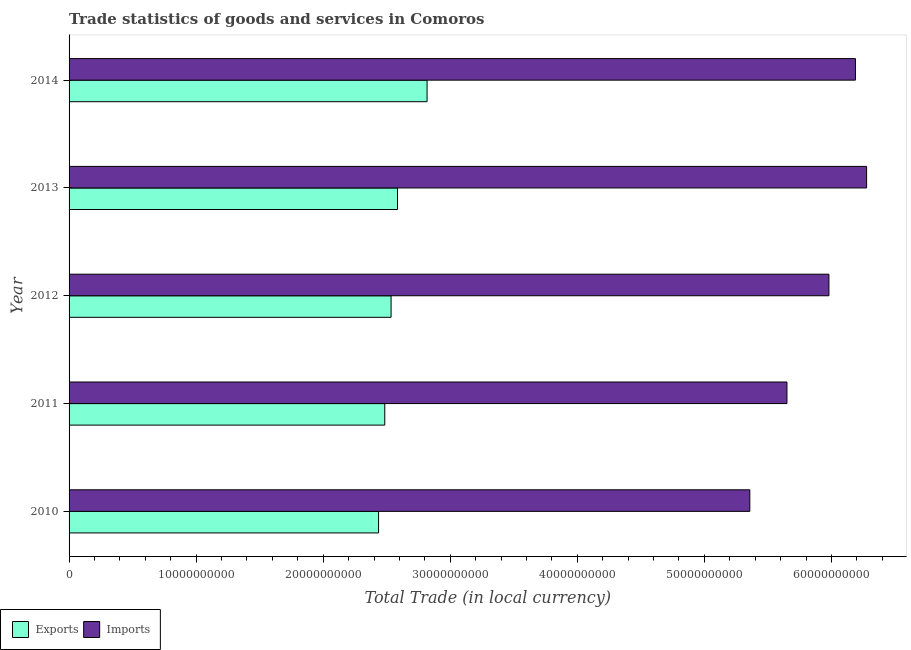How many bars are there on the 1st tick from the top?
Give a very brief answer. 2. How many bars are there on the 2nd tick from the bottom?
Provide a short and direct response. 2. What is the imports of goods and services in 2012?
Make the answer very short. 5.98e+1. Across all years, what is the maximum export of goods and services?
Keep it short and to the point. 2.82e+1. Across all years, what is the minimum imports of goods and services?
Keep it short and to the point. 5.36e+1. In which year was the export of goods and services maximum?
Give a very brief answer. 2014. In which year was the imports of goods and services minimum?
Make the answer very short. 2010. What is the total imports of goods and services in the graph?
Provide a succinct answer. 2.95e+11. What is the difference between the export of goods and services in 2010 and that in 2012?
Give a very brief answer. -9.84e+08. What is the difference between the export of goods and services in 2014 and the imports of goods and services in 2012?
Your answer should be compact. -3.16e+1. What is the average export of goods and services per year?
Give a very brief answer. 2.57e+1. In the year 2012, what is the difference between the export of goods and services and imports of goods and services?
Keep it short and to the point. -3.45e+1. What is the ratio of the export of goods and services in 2012 to that in 2014?
Provide a short and direct response. 0.9. Is the difference between the export of goods and services in 2010 and 2012 greater than the difference between the imports of goods and services in 2010 and 2012?
Provide a short and direct response. Yes. What is the difference between the highest and the second highest export of goods and services?
Ensure brevity in your answer.  2.33e+09. What is the difference between the highest and the lowest imports of goods and services?
Ensure brevity in your answer.  9.19e+09. In how many years, is the imports of goods and services greater than the average imports of goods and services taken over all years?
Offer a very short reply. 3. What does the 1st bar from the top in 2011 represents?
Offer a terse response. Imports. What does the 1st bar from the bottom in 2014 represents?
Your answer should be very brief. Exports. How many bars are there?
Make the answer very short. 10. What is the difference between two consecutive major ticks on the X-axis?
Keep it short and to the point. 1.00e+1. Are the values on the major ticks of X-axis written in scientific E-notation?
Keep it short and to the point. No. Does the graph contain grids?
Your answer should be very brief. No. How many legend labels are there?
Provide a succinct answer. 2. How are the legend labels stacked?
Your answer should be compact. Horizontal. What is the title of the graph?
Keep it short and to the point. Trade statistics of goods and services in Comoros. Does "Constant 2005 US$" appear as one of the legend labels in the graph?
Your response must be concise. No. What is the label or title of the X-axis?
Your answer should be very brief. Total Trade (in local currency). What is the Total Trade (in local currency) of Exports in 2010?
Make the answer very short. 2.44e+1. What is the Total Trade (in local currency) of Imports in 2010?
Your answer should be very brief. 5.36e+1. What is the Total Trade (in local currency) in Exports in 2011?
Your answer should be compact. 2.48e+1. What is the Total Trade (in local currency) in Imports in 2011?
Give a very brief answer. 5.65e+1. What is the Total Trade (in local currency) in Exports in 2012?
Provide a succinct answer. 2.53e+1. What is the Total Trade (in local currency) of Imports in 2012?
Keep it short and to the point. 5.98e+1. What is the Total Trade (in local currency) in Exports in 2013?
Give a very brief answer. 2.58e+1. What is the Total Trade (in local currency) of Imports in 2013?
Keep it short and to the point. 6.28e+1. What is the Total Trade (in local currency) in Exports in 2014?
Provide a short and direct response. 2.82e+1. What is the Total Trade (in local currency) of Imports in 2014?
Offer a very short reply. 6.19e+1. Across all years, what is the maximum Total Trade (in local currency) in Exports?
Offer a terse response. 2.82e+1. Across all years, what is the maximum Total Trade (in local currency) in Imports?
Give a very brief answer. 6.28e+1. Across all years, what is the minimum Total Trade (in local currency) of Exports?
Keep it short and to the point. 2.44e+1. Across all years, what is the minimum Total Trade (in local currency) of Imports?
Your answer should be very brief. 5.36e+1. What is the total Total Trade (in local currency) of Exports in the graph?
Provide a succinct answer. 1.29e+11. What is the total Total Trade (in local currency) in Imports in the graph?
Offer a very short reply. 2.95e+11. What is the difference between the Total Trade (in local currency) in Exports in 2010 and that in 2011?
Provide a short and direct response. -4.87e+08. What is the difference between the Total Trade (in local currency) in Imports in 2010 and that in 2011?
Offer a very short reply. -2.92e+09. What is the difference between the Total Trade (in local currency) of Exports in 2010 and that in 2012?
Your answer should be very brief. -9.84e+08. What is the difference between the Total Trade (in local currency) of Imports in 2010 and that in 2012?
Make the answer very short. -6.23e+09. What is the difference between the Total Trade (in local currency) of Exports in 2010 and that in 2013?
Ensure brevity in your answer.  -1.49e+09. What is the difference between the Total Trade (in local currency) in Imports in 2010 and that in 2013?
Give a very brief answer. -9.19e+09. What is the difference between the Total Trade (in local currency) in Exports in 2010 and that in 2014?
Provide a succinct answer. -3.82e+09. What is the difference between the Total Trade (in local currency) in Imports in 2010 and that in 2014?
Make the answer very short. -8.31e+09. What is the difference between the Total Trade (in local currency) in Exports in 2011 and that in 2012?
Provide a short and direct response. -4.97e+08. What is the difference between the Total Trade (in local currency) in Imports in 2011 and that in 2012?
Give a very brief answer. -3.30e+09. What is the difference between the Total Trade (in local currency) of Exports in 2011 and that in 2013?
Ensure brevity in your answer.  -1.00e+09. What is the difference between the Total Trade (in local currency) of Imports in 2011 and that in 2013?
Your answer should be compact. -6.27e+09. What is the difference between the Total Trade (in local currency) in Exports in 2011 and that in 2014?
Make the answer very short. -3.33e+09. What is the difference between the Total Trade (in local currency) in Imports in 2011 and that in 2014?
Provide a short and direct response. -5.39e+09. What is the difference between the Total Trade (in local currency) in Exports in 2012 and that in 2013?
Offer a terse response. -5.07e+08. What is the difference between the Total Trade (in local currency) in Imports in 2012 and that in 2013?
Keep it short and to the point. -2.97e+09. What is the difference between the Total Trade (in local currency) in Exports in 2012 and that in 2014?
Your answer should be very brief. -2.83e+09. What is the difference between the Total Trade (in local currency) in Imports in 2012 and that in 2014?
Provide a succinct answer. -2.09e+09. What is the difference between the Total Trade (in local currency) of Exports in 2013 and that in 2014?
Keep it short and to the point. -2.33e+09. What is the difference between the Total Trade (in local currency) in Imports in 2013 and that in 2014?
Ensure brevity in your answer.  8.79e+08. What is the difference between the Total Trade (in local currency) of Exports in 2010 and the Total Trade (in local currency) of Imports in 2011?
Make the answer very short. -3.21e+1. What is the difference between the Total Trade (in local currency) in Exports in 2010 and the Total Trade (in local currency) in Imports in 2012?
Offer a very short reply. -3.54e+1. What is the difference between the Total Trade (in local currency) of Exports in 2010 and the Total Trade (in local currency) of Imports in 2013?
Provide a short and direct response. -3.84e+1. What is the difference between the Total Trade (in local currency) of Exports in 2010 and the Total Trade (in local currency) of Imports in 2014?
Your answer should be very brief. -3.75e+1. What is the difference between the Total Trade (in local currency) in Exports in 2011 and the Total Trade (in local currency) in Imports in 2012?
Ensure brevity in your answer.  -3.50e+1. What is the difference between the Total Trade (in local currency) in Exports in 2011 and the Total Trade (in local currency) in Imports in 2013?
Your answer should be compact. -3.79e+1. What is the difference between the Total Trade (in local currency) in Exports in 2011 and the Total Trade (in local currency) in Imports in 2014?
Offer a very short reply. -3.70e+1. What is the difference between the Total Trade (in local currency) of Exports in 2012 and the Total Trade (in local currency) of Imports in 2013?
Keep it short and to the point. -3.74e+1. What is the difference between the Total Trade (in local currency) in Exports in 2012 and the Total Trade (in local currency) in Imports in 2014?
Give a very brief answer. -3.65e+1. What is the difference between the Total Trade (in local currency) in Exports in 2013 and the Total Trade (in local currency) in Imports in 2014?
Make the answer very short. -3.60e+1. What is the average Total Trade (in local currency) in Exports per year?
Your response must be concise. 2.57e+1. What is the average Total Trade (in local currency) of Imports per year?
Provide a succinct answer. 5.89e+1. In the year 2010, what is the difference between the Total Trade (in local currency) of Exports and Total Trade (in local currency) of Imports?
Offer a very short reply. -2.92e+1. In the year 2011, what is the difference between the Total Trade (in local currency) in Exports and Total Trade (in local currency) in Imports?
Offer a very short reply. -3.17e+1. In the year 2012, what is the difference between the Total Trade (in local currency) in Exports and Total Trade (in local currency) in Imports?
Keep it short and to the point. -3.45e+1. In the year 2013, what is the difference between the Total Trade (in local currency) of Exports and Total Trade (in local currency) of Imports?
Keep it short and to the point. -3.69e+1. In the year 2014, what is the difference between the Total Trade (in local currency) of Exports and Total Trade (in local currency) of Imports?
Keep it short and to the point. -3.37e+1. What is the ratio of the Total Trade (in local currency) of Exports in 2010 to that in 2011?
Give a very brief answer. 0.98. What is the ratio of the Total Trade (in local currency) of Imports in 2010 to that in 2011?
Your response must be concise. 0.95. What is the ratio of the Total Trade (in local currency) of Exports in 2010 to that in 2012?
Your answer should be very brief. 0.96. What is the ratio of the Total Trade (in local currency) in Imports in 2010 to that in 2012?
Keep it short and to the point. 0.9. What is the ratio of the Total Trade (in local currency) of Exports in 2010 to that in 2013?
Keep it short and to the point. 0.94. What is the ratio of the Total Trade (in local currency) in Imports in 2010 to that in 2013?
Offer a very short reply. 0.85. What is the ratio of the Total Trade (in local currency) of Exports in 2010 to that in 2014?
Provide a succinct answer. 0.86. What is the ratio of the Total Trade (in local currency) of Imports in 2010 to that in 2014?
Offer a very short reply. 0.87. What is the ratio of the Total Trade (in local currency) of Exports in 2011 to that in 2012?
Offer a terse response. 0.98. What is the ratio of the Total Trade (in local currency) in Imports in 2011 to that in 2012?
Provide a short and direct response. 0.94. What is the ratio of the Total Trade (in local currency) of Exports in 2011 to that in 2013?
Keep it short and to the point. 0.96. What is the ratio of the Total Trade (in local currency) in Imports in 2011 to that in 2013?
Ensure brevity in your answer.  0.9. What is the ratio of the Total Trade (in local currency) in Exports in 2011 to that in 2014?
Your response must be concise. 0.88. What is the ratio of the Total Trade (in local currency) of Imports in 2011 to that in 2014?
Keep it short and to the point. 0.91. What is the ratio of the Total Trade (in local currency) of Exports in 2012 to that in 2013?
Offer a terse response. 0.98. What is the ratio of the Total Trade (in local currency) in Imports in 2012 to that in 2013?
Provide a short and direct response. 0.95. What is the ratio of the Total Trade (in local currency) in Exports in 2012 to that in 2014?
Keep it short and to the point. 0.9. What is the ratio of the Total Trade (in local currency) of Imports in 2012 to that in 2014?
Provide a short and direct response. 0.97. What is the ratio of the Total Trade (in local currency) in Exports in 2013 to that in 2014?
Your answer should be compact. 0.92. What is the ratio of the Total Trade (in local currency) of Imports in 2013 to that in 2014?
Give a very brief answer. 1.01. What is the difference between the highest and the second highest Total Trade (in local currency) of Exports?
Offer a terse response. 2.33e+09. What is the difference between the highest and the second highest Total Trade (in local currency) of Imports?
Keep it short and to the point. 8.79e+08. What is the difference between the highest and the lowest Total Trade (in local currency) in Exports?
Your answer should be very brief. 3.82e+09. What is the difference between the highest and the lowest Total Trade (in local currency) in Imports?
Make the answer very short. 9.19e+09. 